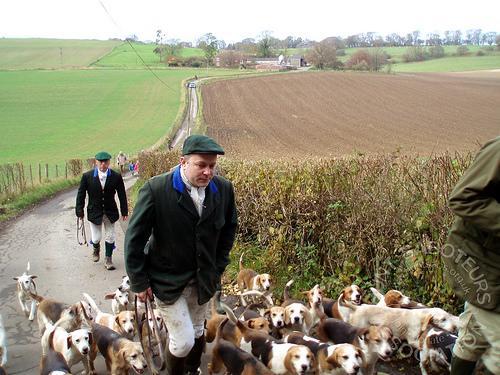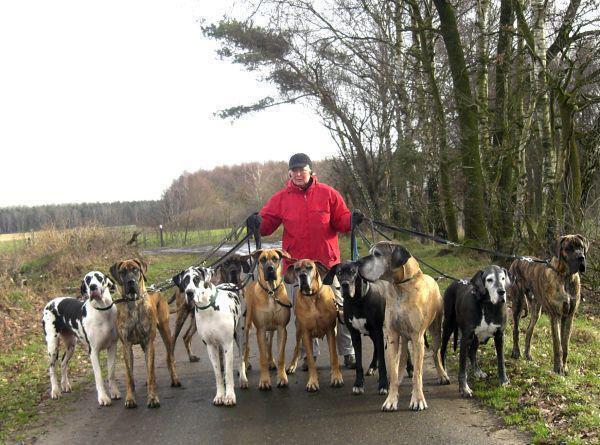The first image is the image on the left, the second image is the image on the right. Assess this claim about the two images: "At least one image shows a man in orange vest and cap holding up a prey animal over a hound dog.". Correct or not? Answer yes or no. No. The first image is the image on the left, the second image is the image on the right. Analyze the images presented: Is the assertion "In at least one of the images, a hunter in a bright orange vest and hat holds a dead animal over a beagle" valid? Answer yes or no. No. 